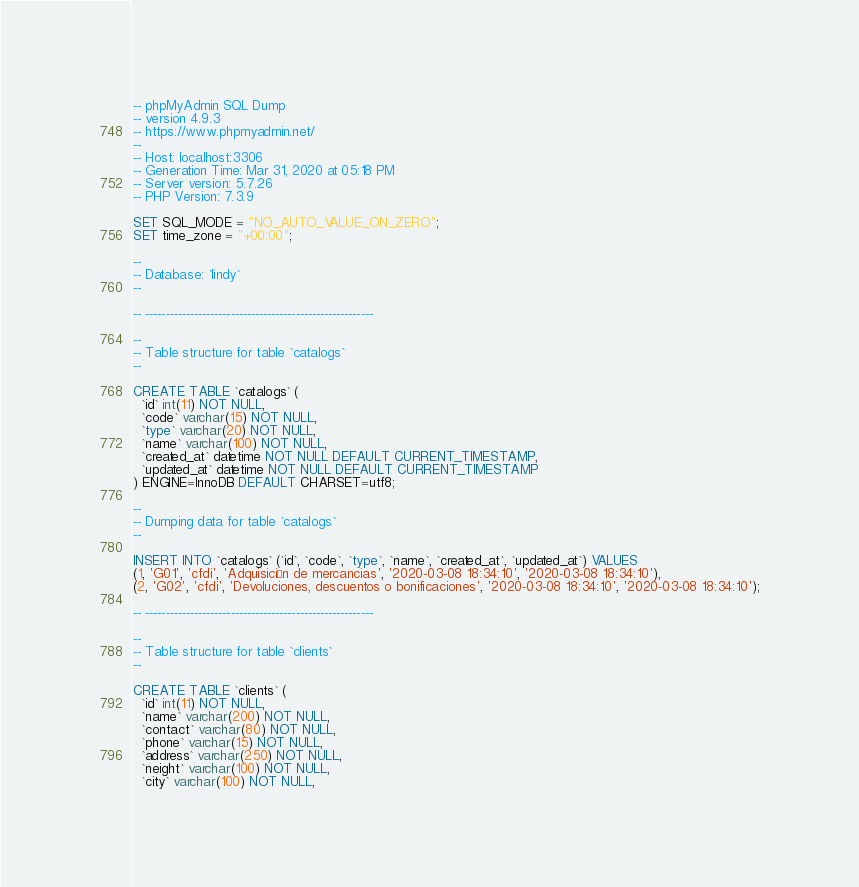<code> <loc_0><loc_0><loc_500><loc_500><_SQL_>-- phpMyAdmin SQL Dump
-- version 4.9.3
-- https://www.phpmyadmin.net/
--
-- Host: localhost:3306
-- Generation Time: Mar 31, 2020 at 05:18 PM
-- Server version: 5.7.26
-- PHP Version: 7.3.9

SET SQL_MODE = "NO_AUTO_VALUE_ON_ZERO";
SET time_zone = "+00:00";

--
-- Database: `lindy`
--

-- --------------------------------------------------------

--
-- Table structure for table `catalogs`
--

CREATE TABLE `catalogs` (
  `id` int(11) NOT NULL,
  `code` varchar(15) NOT NULL,
  `type` varchar(20) NOT NULL,
  `name` varchar(100) NOT NULL,
  `created_at` datetime NOT NULL DEFAULT CURRENT_TIMESTAMP,
  `updated_at` datetime NOT NULL DEFAULT CURRENT_TIMESTAMP
) ENGINE=InnoDB DEFAULT CHARSET=utf8;

--
-- Dumping data for table `catalogs`
--

INSERT INTO `catalogs` (`id`, `code`, `type`, `name`, `created_at`, `updated_at`) VALUES
(1, 'G01', 'cfdi', 'Adquisición de mercancias', '2020-03-08 18:34:10', '2020-03-08 18:34:10'),
(2, 'G02', 'cfdi', 'Devoluciones, descuentos o bonificaciones', '2020-03-08 18:34:10', '2020-03-08 18:34:10');

-- --------------------------------------------------------

--
-- Table structure for table `clients`
--

CREATE TABLE `clients` (
  `id` int(11) NOT NULL,
  `name` varchar(200) NOT NULL,
  `contact` varchar(80) NOT NULL,
  `phone` varchar(15) NOT NULL,
  `address` varchar(250) NOT NULL,
  `neight` varchar(100) NOT NULL,
  `city` varchar(100) NOT NULL,</code> 